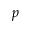Convert formula to latex. <formula><loc_0><loc_0><loc_500><loc_500>p</formula> 